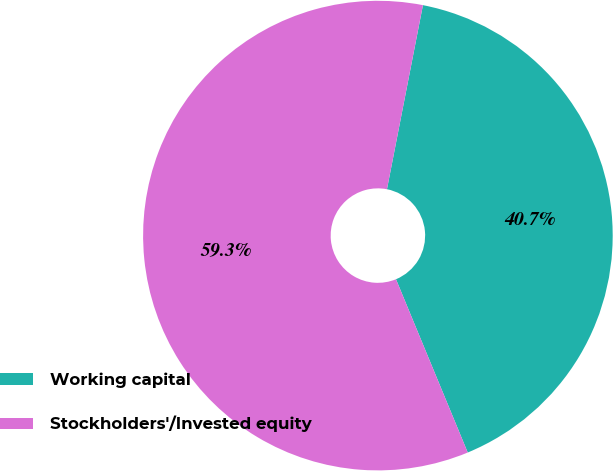Convert chart. <chart><loc_0><loc_0><loc_500><loc_500><pie_chart><fcel>Working capital<fcel>Stockholders'/Invested equity<nl><fcel>40.68%<fcel>59.32%<nl></chart> 